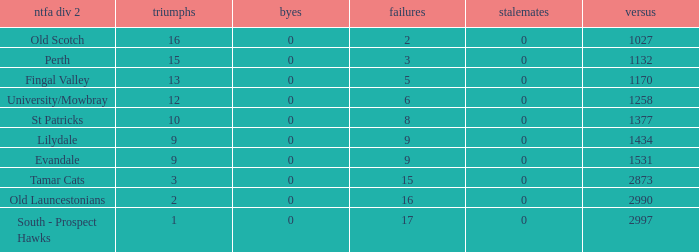What is the lowest number of against of NTFA Div 2 Fingal Valley? 1170.0. 